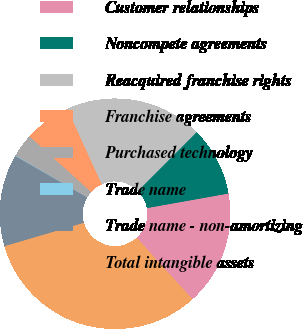<chart> <loc_0><loc_0><loc_500><loc_500><pie_chart><fcel>Customer relationships<fcel>Noncompete agreements<fcel>Reacquired franchise rights<fcel>Franchise agreements<fcel>Purchased technology<fcel>Trade name<fcel>Trade name - non-amortizing<fcel>Total intangible assets<nl><fcel>16.11%<fcel>9.69%<fcel>19.31%<fcel>6.49%<fcel>3.28%<fcel>0.07%<fcel>12.9%<fcel>32.14%<nl></chart> 